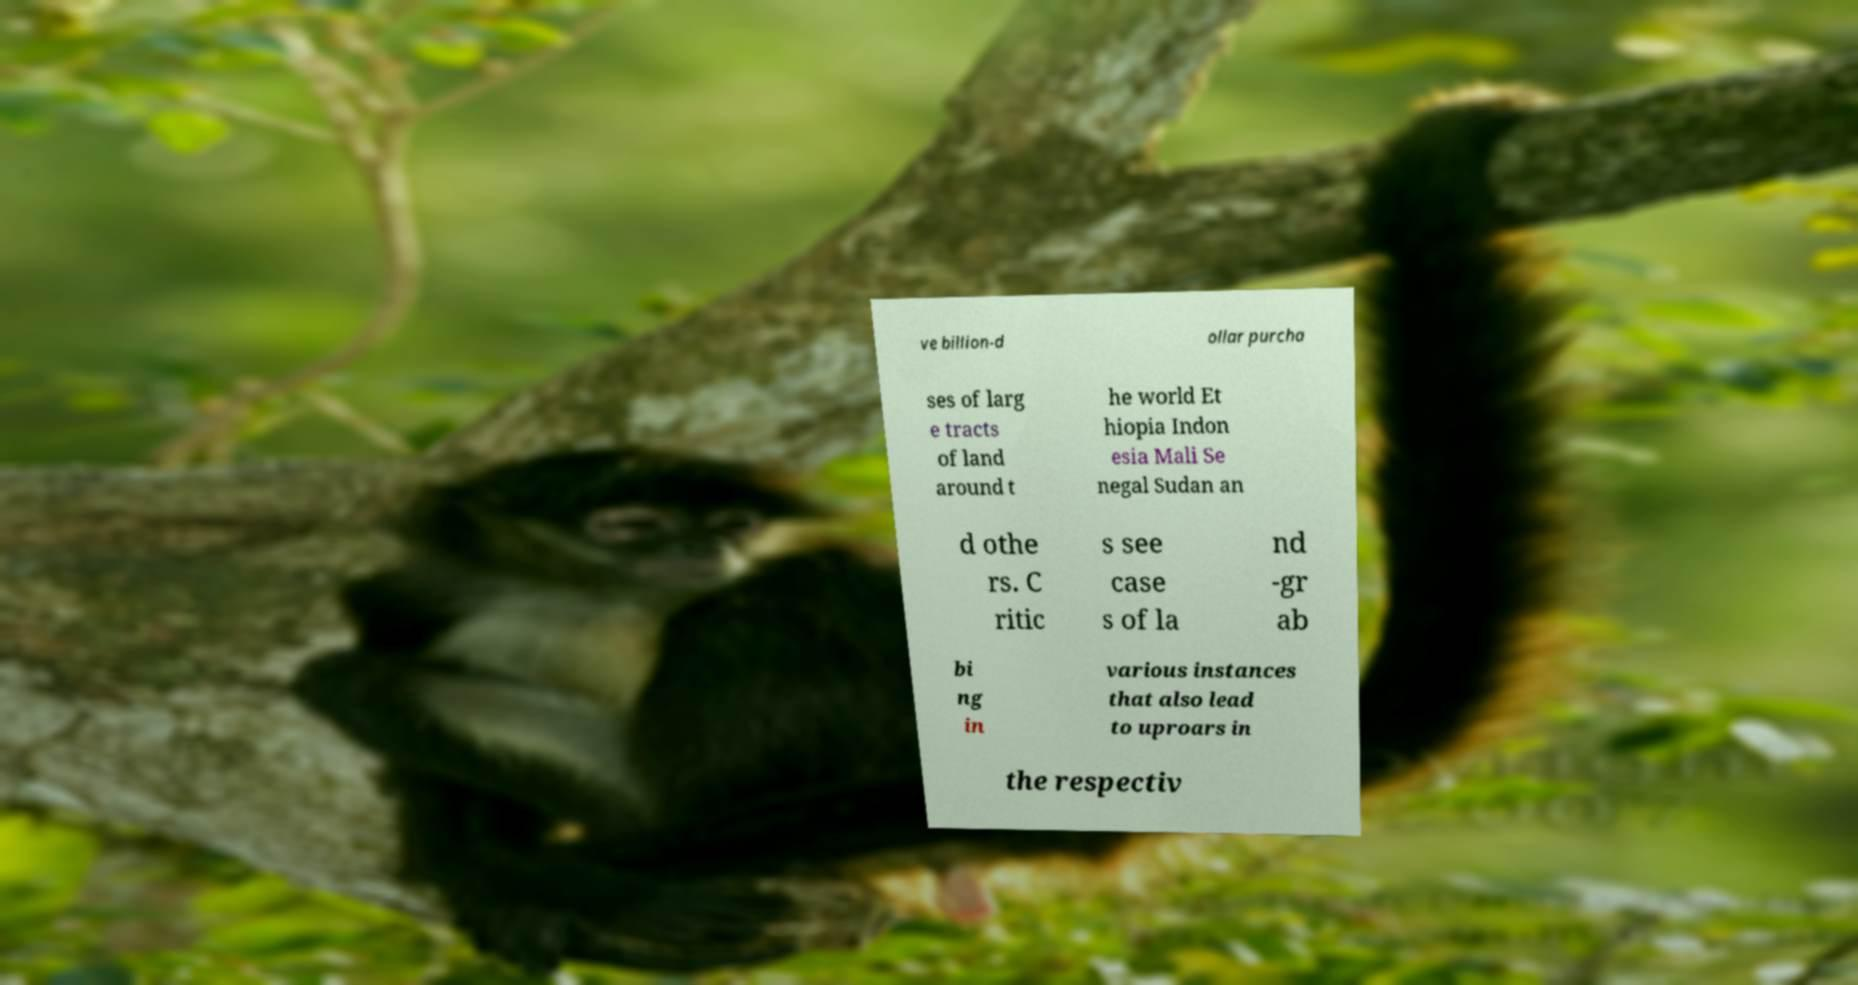Please identify and transcribe the text found in this image. ve billion-d ollar purcha ses of larg e tracts of land around t he world Et hiopia Indon esia Mali Se negal Sudan an d othe rs. C ritic s see case s of la nd -gr ab bi ng in various instances that also lead to uproars in the respectiv 